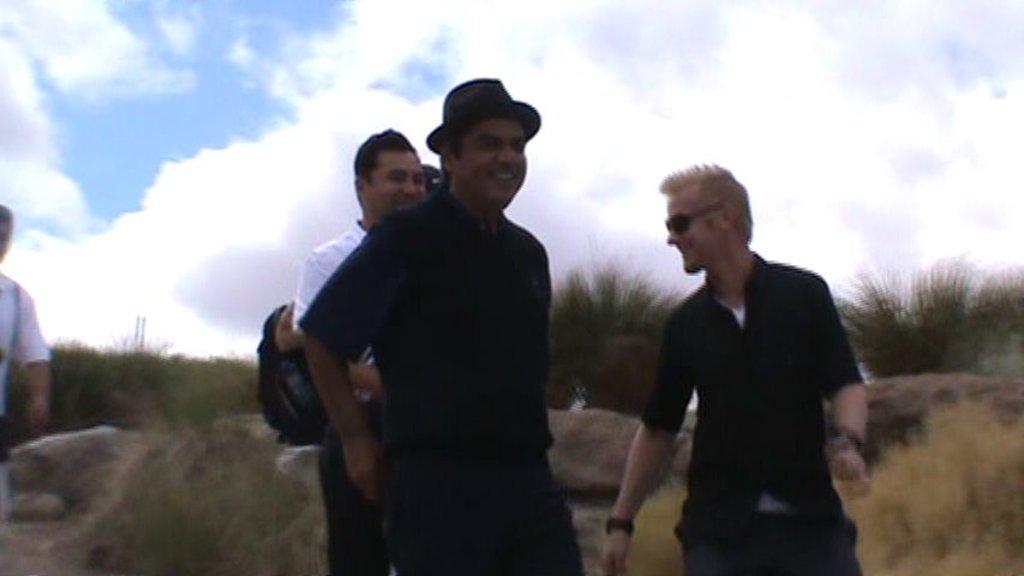In one or two sentences, can you explain what this image depicts? In the center of the image there are people. In the background of the image there is grass.. There are stones. At the top of the image there is sky and clouds. 